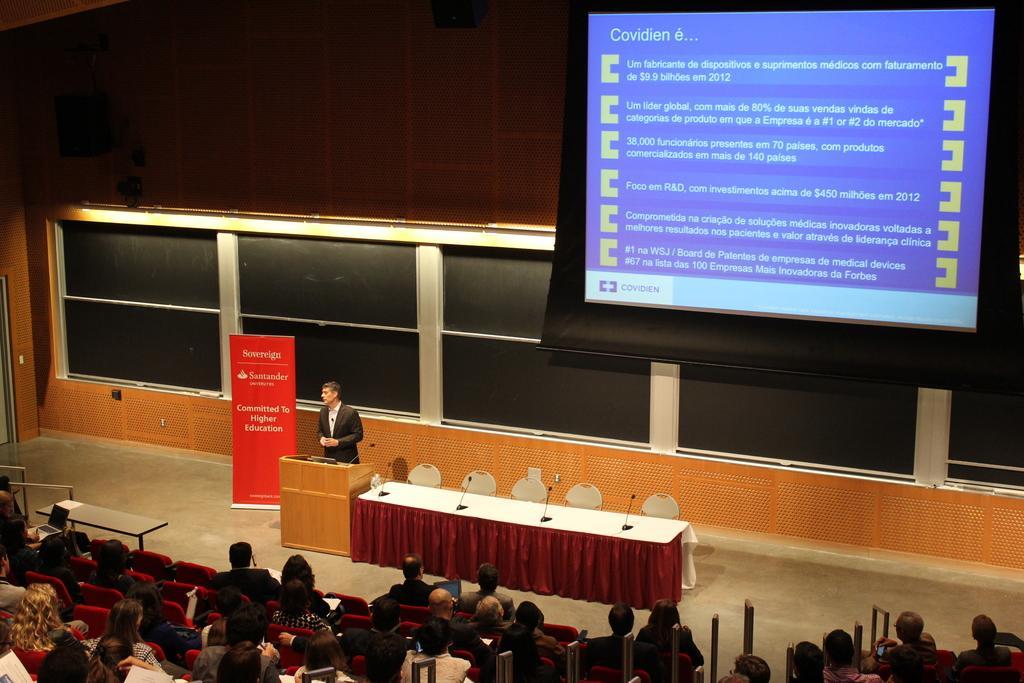In one or two sentences, can you explain what this image depicts? In this image at the bottom there are a group of people who are sitting on chairs, and in the center there is one person standing. In front of him there is podium and table, on the table there are some mics and also there are some chairs. At the top there is screen, and in the center there are some windows and board. On the board there is some text, and in the background there is wall. 